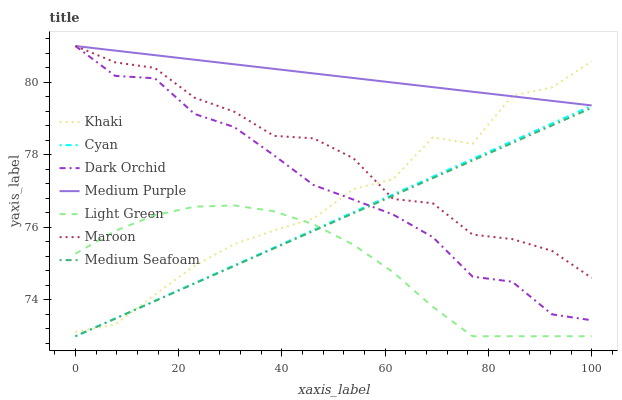Does Light Green have the minimum area under the curve?
Answer yes or no. Yes. Does Medium Purple have the maximum area under the curve?
Answer yes or no. Yes. Does Maroon have the minimum area under the curve?
Answer yes or no. No. Does Maroon have the maximum area under the curve?
Answer yes or no. No. Is Medium Purple the smoothest?
Answer yes or no. Yes. Is Khaki the roughest?
Answer yes or no. Yes. Is Maroon the smoothest?
Answer yes or no. No. Is Maroon the roughest?
Answer yes or no. No. Does Light Green have the lowest value?
Answer yes or no. Yes. Does Maroon have the lowest value?
Answer yes or no. No. Does Dark Orchid have the highest value?
Answer yes or no. Yes. Does Light Green have the highest value?
Answer yes or no. No. Is Light Green less than Dark Orchid?
Answer yes or no. Yes. Is Medium Purple greater than Light Green?
Answer yes or no. Yes. Does Medium Purple intersect Khaki?
Answer yes or no. Yes. Is Medium Purple less than Khaki?
Answer yes or no. No. Is Medium Purple greater than Khaki?
Answer yes or no. No. Does Light Green intersect Dark Orchid?
Answer yes or no. No. 